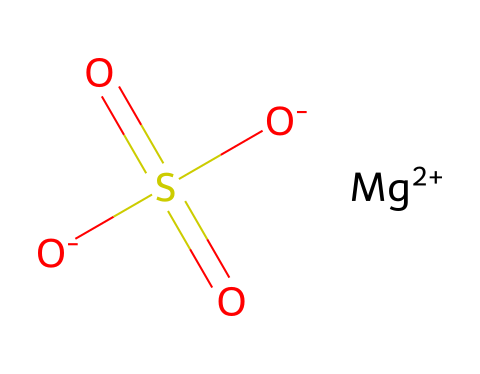What is the molar mass of magnesium sulfate? To find the molar mass, add the atomic masses of each element in the formula. Magnesium (Mg) has an atomic mass of about 24.31 g/mol, sulfur (S) about 32.07 g/mol, and each oxygen (O) about 16.00 g/mol. There are 4 oxygen atoms, so total = 24.31 + 32.07 + (4 × 16.00) = 120.37 g/mol.
Answer: 120.37 g/mol How many oxygen atoms are present in magnesium sulfate? In the SMILES representation, we can see that there are four oxygen atoms denoted by the [O-] and O in the S(=O)(=O)[O-]. This indicates a total of 4 oxygen atoms.
Answer: 4 What is the charge on the magnesium ion? The SMILES indicates that magnesium is represented as [Mg+2], showing that it has a +2 charge.
Answer: +2 What type of compound is magnesium sulfate considered? Magnesium sulfate is classified as an electrolyte because it dissociates into ions when dissolved in water, allowing it to conduct electricity.
Answer: electrolyte How many total atoms are in the magnesium sulfate molecule? To count the total atoms, we sum the atoms: 1 magnesium (Mg), 1 sulfur (S), and 4 oxygens (O), giving 6 atoms in total.
Answer: 6 What functional groups are indicated in the structure of magnesium sulfate? The structure shows a sulfate group (SO4) indicated by S(=O)(=O)[O-], indicating this is the functional group present in magnesium sulfate.
Answer: sulfate group 